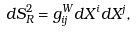Convert formula to latex. <formula><loc_0><loc_0><loc_500><loc_500>d S ^ { 2 } _ { R } = g ^ { W } _ { i j } d X ^ { i } d X ^ { j } ,</formula> 